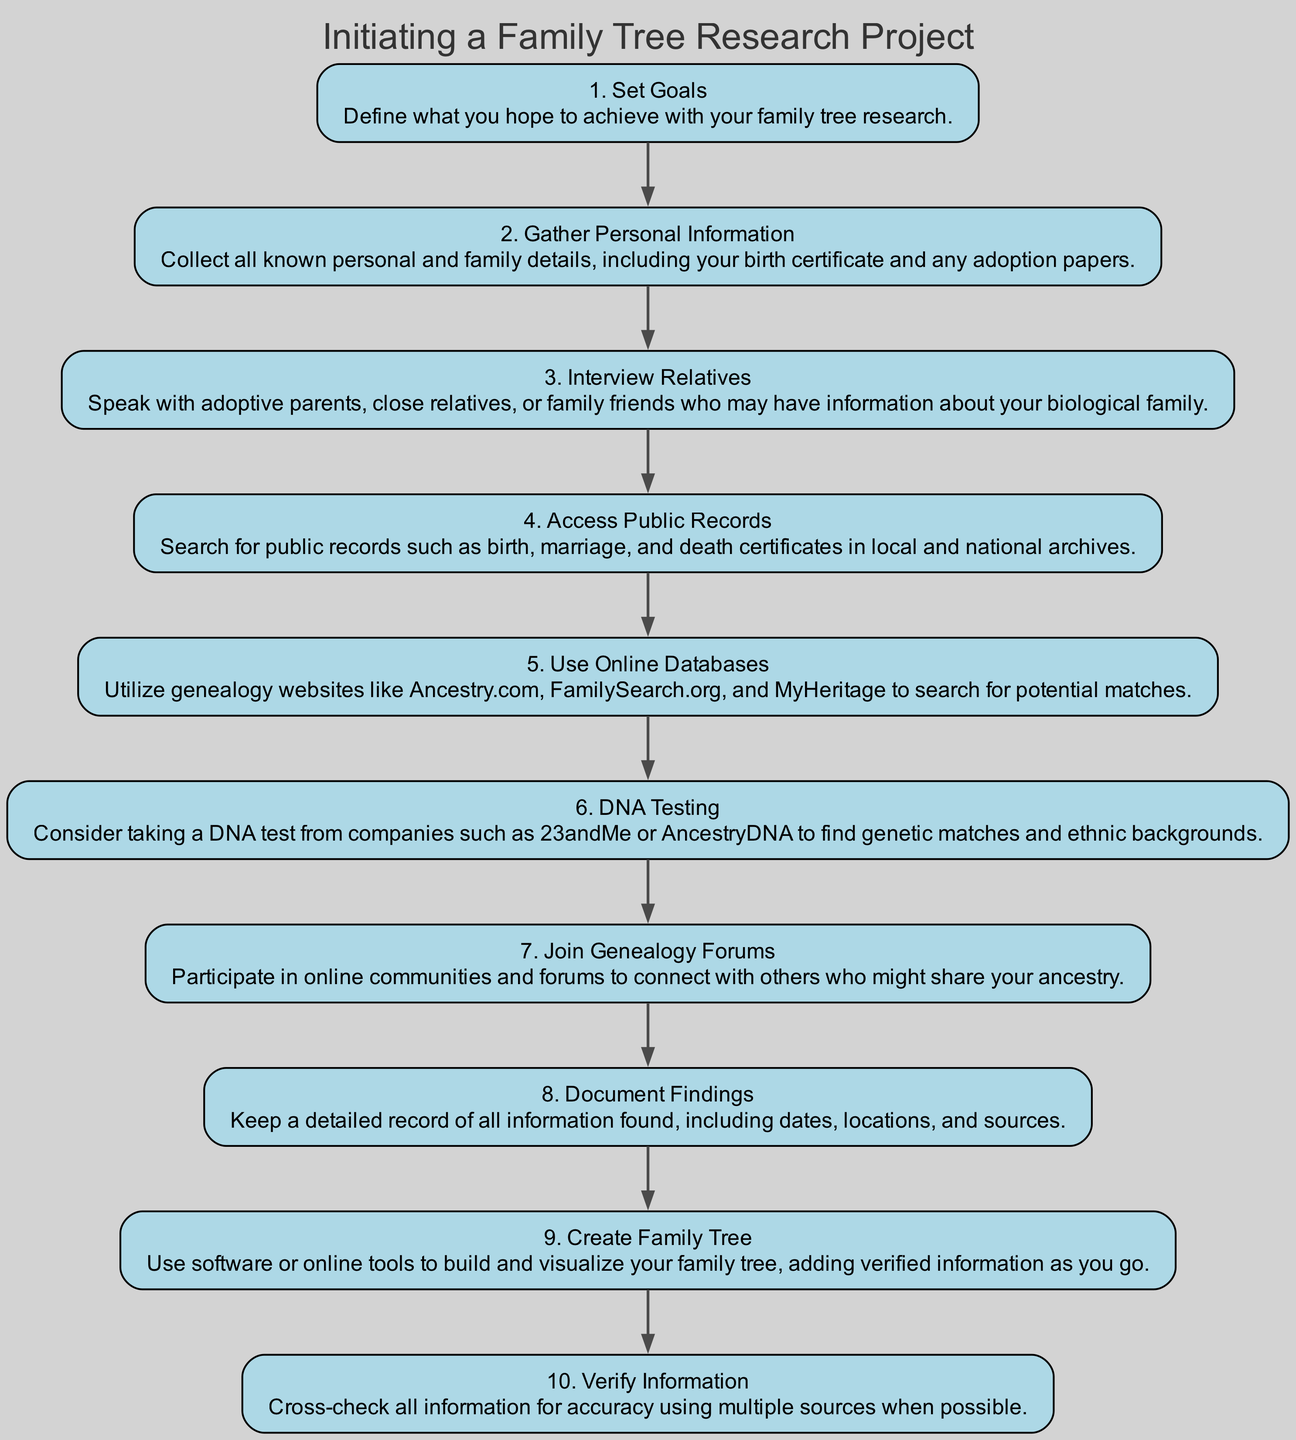What is the first step in the family tree research project? The first step is labeled "1. Set Goals" and is described as defining what you hope to achieve with your family tree research.
Answer: Set Goals How many steps are there in the family tree research process? Counting the steps listed in the diagram, there are a total of 10 steps outlined in the project.
Answer: 10 What is the last step in the diagram? The last step is labeled "10. Verify Information" and involves cross-checking all gathered information for accuracy.
Answer: Verify Information Which step involves using online resources for research? The step labeled "5. Use Online Databases" describes utilizing genealogy websites to search for potential matches.
Answer: Use Online Databases What is the relationship between "Interview Relatives" and "Access Public Records"? "Interview Relatives" is the third step and "Access Public Records" is the fourth step, meaning the former is followed by the latter, making them sequential steps in the process.
Answer: Sequential 